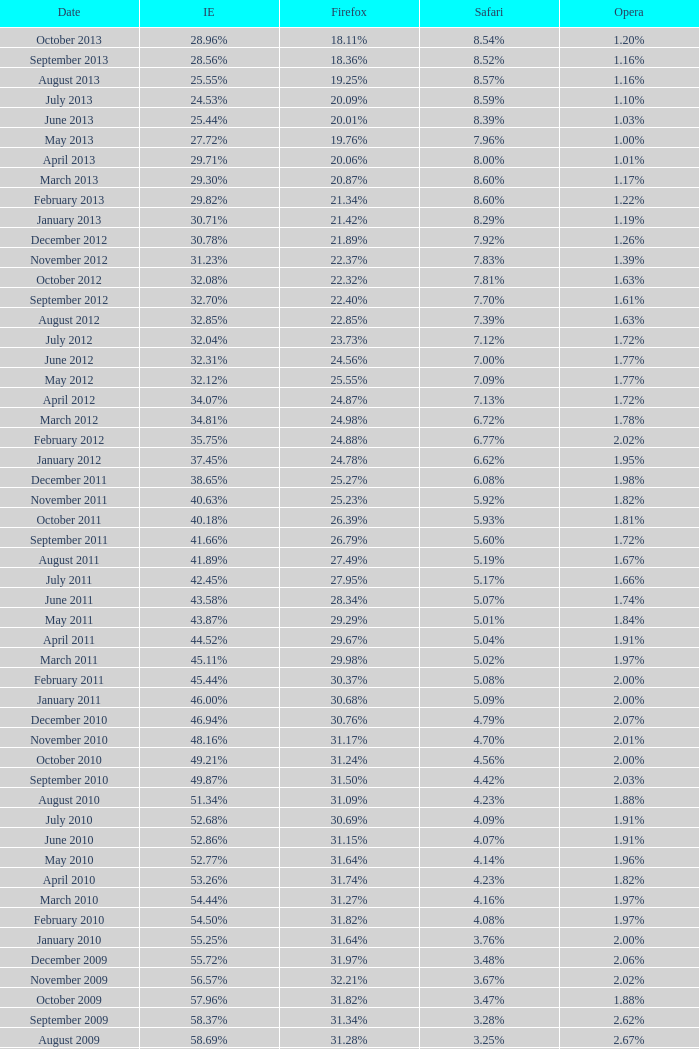What proportion of browsers utilized opera in october 2010? 2.00%. I'm looking to parse the entire table for insights. Could you assist me with that? {'header': ['Date', 'IE', 'Firefox', 'Safari', 'Opera'], 'rows': [['October 2013', '28.96%', '18.11%', '8.54%', '1.20%'], ['September 2013', '28.56%', '18.36%', '8.52%', '1.16%'], ['August 2013', '25.55%', '19.25%', '8.57%', '1.16%'], ['July 2013', '24.53%', '20.09%', '8.59%', '1.10%'], ['June 2013', '25.44%', '20.01%', '8.39%', '1.03%'], ['May 2013', '27.72%', '19.76%', '7.96%', '1.00%'], ['April 2013', '29.71%', '20.06%', '8.00%', '1.01%'], ['March 2013', '29.30%', '20.87%', '8.60%', '1.17%'], ['February 2013', '29.82%', '21.34%', '8.60%', '1.22%'], ['January 2013', '30.71%', '21.42%', '8.29%', '1.19%'], ['December 2012', '30.78%', '21.89%', '7.92%', '1.26%'], ['November 2012', '31.23%', '22.37%', '7.83%', '1.39%'], ['October 2012', '32.08%', '22.32%', '7.81%', '1.63%'], ['September 2012', '32.70%', '22.40%', '7.70%', '1.61%'], ['August 2012', '32.85%', '22.85%', '7.39%', '1.63%'], ['July 2012', '32.04%', '23.73%', '7.12%', '1.72%'], ['June 2012', '32.31%', '24.56%', '7.00%', '1.77%'], ['May 2012', '32.12%', '25.55%', '7.09%', '1.77%'], ['April 2012', '34.07%', '24.87%', '7.13%', '1.72%'], ['March 2012', '34.81%', '24.98%', '6.72%', '1.78%'], ['February 2012', '35.75%', '24.88%', '6.77%', '2.02%'], ['January 2012', '37.45%', '24.78%', '6.62%', '1.95%'], ['December 2011', '38.65%', '25.27%', '6.08%', '1.98%'], ['November 2011', '40.63%', '25.23%', '5.92%', '1.82%'], ['October 2011', '40.18%', '26.39%', '5.93%', '1.81%'], ['September 2011', '41.66%', '26.79%', '5.60%', '1.72%'], ['August 2011', '41.89%', '27.49%', '5.19%', '1.67%'], ['July 2011', '42.45%', '27.95%', '5.17%', '1.66%'], ['June 2011', '43.58%', '28.34%', '5.07%', '1.74%'], ['May 2011', '43.87%', '29.29%', '5.01%', '1.84%'], ['April 2011', '44.52%', '29.67%', '5.04%', '1.91%'], ['March 2011', '45.11%', '29.98%', '5.02%', '1.97%'], ['February 2011', '45.44%', '30.37%', '5.08%', '2.00%'], ['January 2011', '46.00%', '30.68%', '5.09%', '2.00%'], ['December 2010', '46.94%', '30.76%', '4.79%', '2.07%'], ['November 2010', '48.16%', '31.17%', '4.70%', '2.01%'], ['October 2010', '49.21%', '31.24%', '4.56%', '2.00%'], ['September 2010', '49.87%', '31.50%', '4.42%', '2.03%'], ['August 2010', '51.34%', '31.09%', '4.23%', '1.88%'], ['July 2010', '52.68%', '30.69%', '4.09%', '1.91%'], ['June 2010', '52.86%', '31.15%', '4.07%', '1.91%'], ['May 2010', '52.77%', '31.64%', '4.14%', '1.96%'], ['April 2010', '53.26%', '31.74%', '4.23%', '1.82%'], ['March 2010', '54.44%', '31.27%', '4.16%', '1.97%'], ['February 2010', '54.50%', '31.82%', '4.08%', '1.97%'], ['January 2010', '55.25%', '31.64%', '3.76%', '2.00%'], ['December 2009', '55.72%', '31.97%', '3.48%', '2.06%'], ['November 2009', '56.57%', '32.21%', '3.67%', '2.02%'], ['October 2009', '57.96%', '31.82%', '3.47%', '1.88%'], ['September 2009', '58.37%', '31.34%', '3.28%', '2.62%'], ['August 2009', '58.69%', '31.28%', '3.25%', '2.67%'], ['July 2009', '60.11%', '30.50%', '3.02%', '2.64%'], ['June 2009', '59.49%', '30.26%', '2.91%', '3.46%'], ['May 2009', '62.09%', '28.75%', '2.65%', '3.23%'], ['April 2009', '61.88%', '29.67%', '2.75%', '2.96%'], ['March 2009', '62.52%', '29.40%', '2.73%', '2.94%'], ['February 2009', '64.43%', '27.85%', '2.59%', '2.95%'], ['January 2009', '65.41%', '27.03%', '2.57%', '2.92%'], ['December 2008', '67.84%', '25.23%', '2.41%', '2.83%'], ['November 2008', '68.14%', '25.27%', '2.49%', '3.01%'], ['October 2008', '67.68%', '25.54%', '2.91%', '2.69%'], ['September2008', '67.16%', '25.77%', '3.00%', '2.86%'], ['August 2008', '68.91%', '26.08%', '2.99%', '1.83%'], ['July 2008', '68.57%', '26.14%', '3.30%', '1.78%']]} 